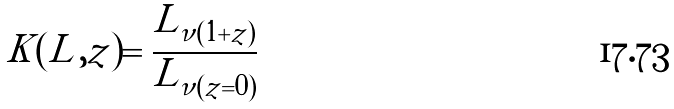<formula> <loc_0><loc_0><loc_500><loc_500>K ( L , z ) = \frac { L _ { \nu ( 1 + z ) } } { L _ { \nu ( z = 0 ) } }</formula> 